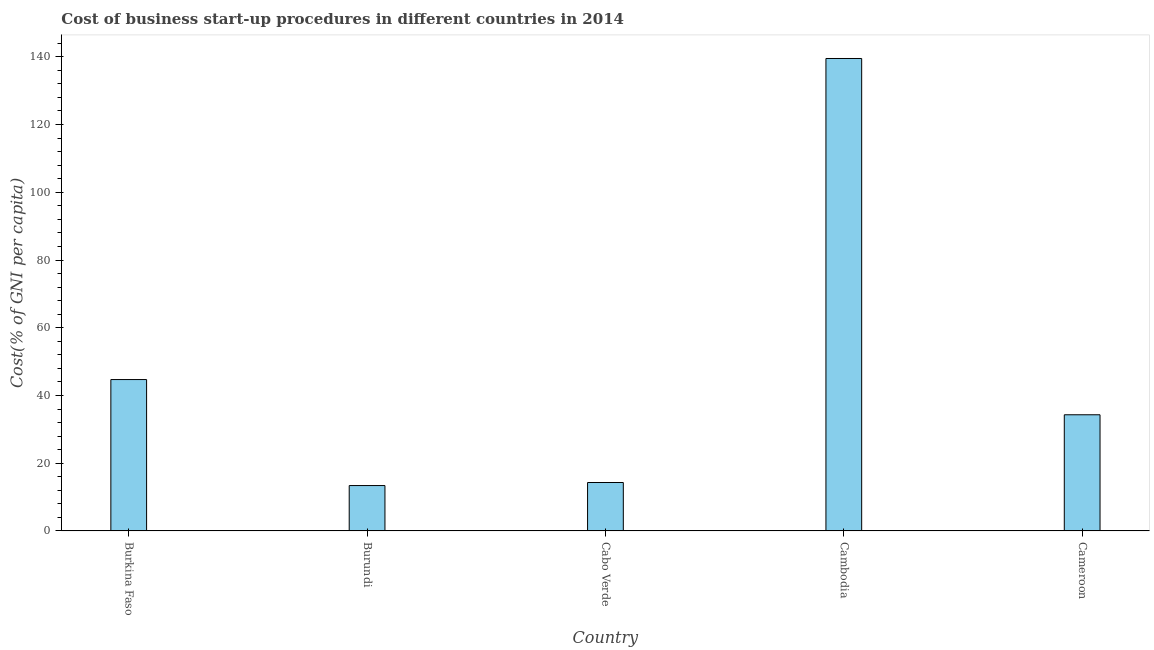What is the title of the graph?
Keep it short and to the point. Cost of business start-up procedures in different countries in 2014. What is the label or title of the Y-axis?
Keep it short and to the point. Cost(% of GNI per capita). Across all countries, what is the maximum cost of business startup procedures?
Ensure brevity in your answer.  139.5. In which country was the cost of business startup procedures maximum?
Your answer should be compact. Cambodia. In which country was the cost of business startup procedures minimum?
Provide a short and direct response. Burundi. What is the sum of the cost of business startup procedures?
Your response must be concise. 246.2. What is the average cost of business startup procedures per country?
Give a very brief answer. 49.24. What is the median cost of business startup procedures?
Provide a succinct answer. 34.3. In how many countries, is the cost of business startup procedures greater than 4 %?
Ensure brevity in your answer.  5. What is the ratio of the cost of business startup procedures in Burundi to that in Cameroon?
Provide a succinct answer. 0.39. Is the cost of business startup procedures in Burundi less than that in Cambodia?
Your answer should be very brief. Yes. Is the difference between the cost of business startup procedures in Burundi and Cameroon greater than the difference between any two countries?
Give a very brief answer. No. What is the difference between the highest and the second highest cost of business startup procedures?
Make the answer very short. 94.8. What is the difference between the highest and the lowest cost of business startup procedures?
Provide a short and direct response. 126.1. In how many countries, is the cost of business startup procedures greater than the average cost of business startup procedures taken over all countries?
Keep it short and to the point. 1. How many bars are there?
Provide a succinct answer. 5. What is the Cost(% of GNI per capita) in Burkina Faso?
Your response must be concise. 44.7. What is the Cost(% of GNI per capita) in Burundi?
Give a very brief answer. 13.4. What is the Cost(% of GNI per capita) in Cambodia?
Ensure brevity in your answer.  139.5. What is the Cost(% of GNI per capita) in Cameroon?
Provide a short and direct response. 34.3. What is the difference between the Cost(% of GNI per capita) in Burkina Faso and Burundi?
Your answer should be very brief. 31.3. What is the difference between the Cost(% of GNI per capita) in Burkina Faso and Cabo Verde?
Provide a succinct answer. 30.4. What is the difference between the Cost(% of GNI per capita) in Burkina Faso and Cambodia?
Provide a short and direct response. -94.8. What is the difference between the Cost(% of GNI per capita) in Burkina Faso and Cameroon?
Keep it short and to the point. 10.4. What is the difference between the Cost(% of GNI per capita) in Burundi and Cambodia?
Your response must be concise. -126.1. What is the difference between the Cost(% of GNI per capita) in Burundi and Cameroon?
Ensure brevity in your answer.  -20.9. What is the difference between the Cost(% of GNI per capita) in Cabo Verde and Cambodia?
Your answer should be very brief. -125.2. What is the difference between the Cost(% of GNI per capita) in Cabo Verde and Cameroon?
Give a very brief answer. -20. What is the difference between the Cost(% of GNI per capita) in Cambodia and Cameroon?
Make the answer very short. 105.2. What is the ratio of the Cost(% of GNI per capita) in Burkina Faso to that in Burundi?
Make the answer very short. 3.34. What is the ratio of the Cost(% of GNI per capita) in Burkina Faso to that in Cabo Verde?
Your answer should be compact. 3.13. What is the ratio of the Cost(% of GNI per capita) in Burkina Faso to that in Cambodia?
Offer a terse response. 0.32. What is the ratio of the Cost(% of GNI per capita) in Burkina Faso to that in Cameroon?
Offer a very short reply. 1.3. What is the ratio of the Cost(% of GNI per capita) in Burundi to that in Cabo Verde?
Provide a short and direct response. 0.94. What is the ratio of the Cost(% of GNI per capita) in Burundi to that in Cambodia?
Give a very brief answer. 0.1. What is the ratio of the Cost(% of GNI per capita) in Burundi to that in Cameroon?
Offer a very short reply. 0.39. What is the ratio of the Cost(% of GNI per capita) in Cabo Verde to that in Cambodia?
Provide a succinct answer. 0.1. What is the ratio of the Cost(% of GNI per capita) in Cabo Verde to that in Cameroon?
Provide a succinct answer. 0.42. What is the ratio of the Cost(% of GNI per capita) in Cambodia to that in Cameroon?
Your response must be concise. 4.07. 